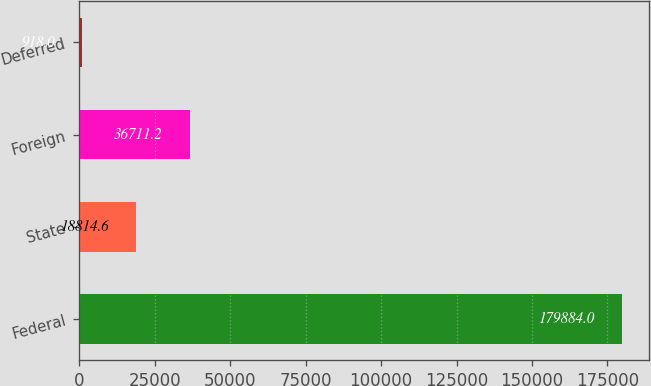Convert chart to OTSL. <chart><loc_0><loc_0><loc_500><loc_500><bar_chart><fcel>Federal<fcel>State<fcel>Foreign<fcel>Deferred<nl><fcel>179884<fcel>18814.6<fcel>36711.2<fcel>918<nl></chart> 